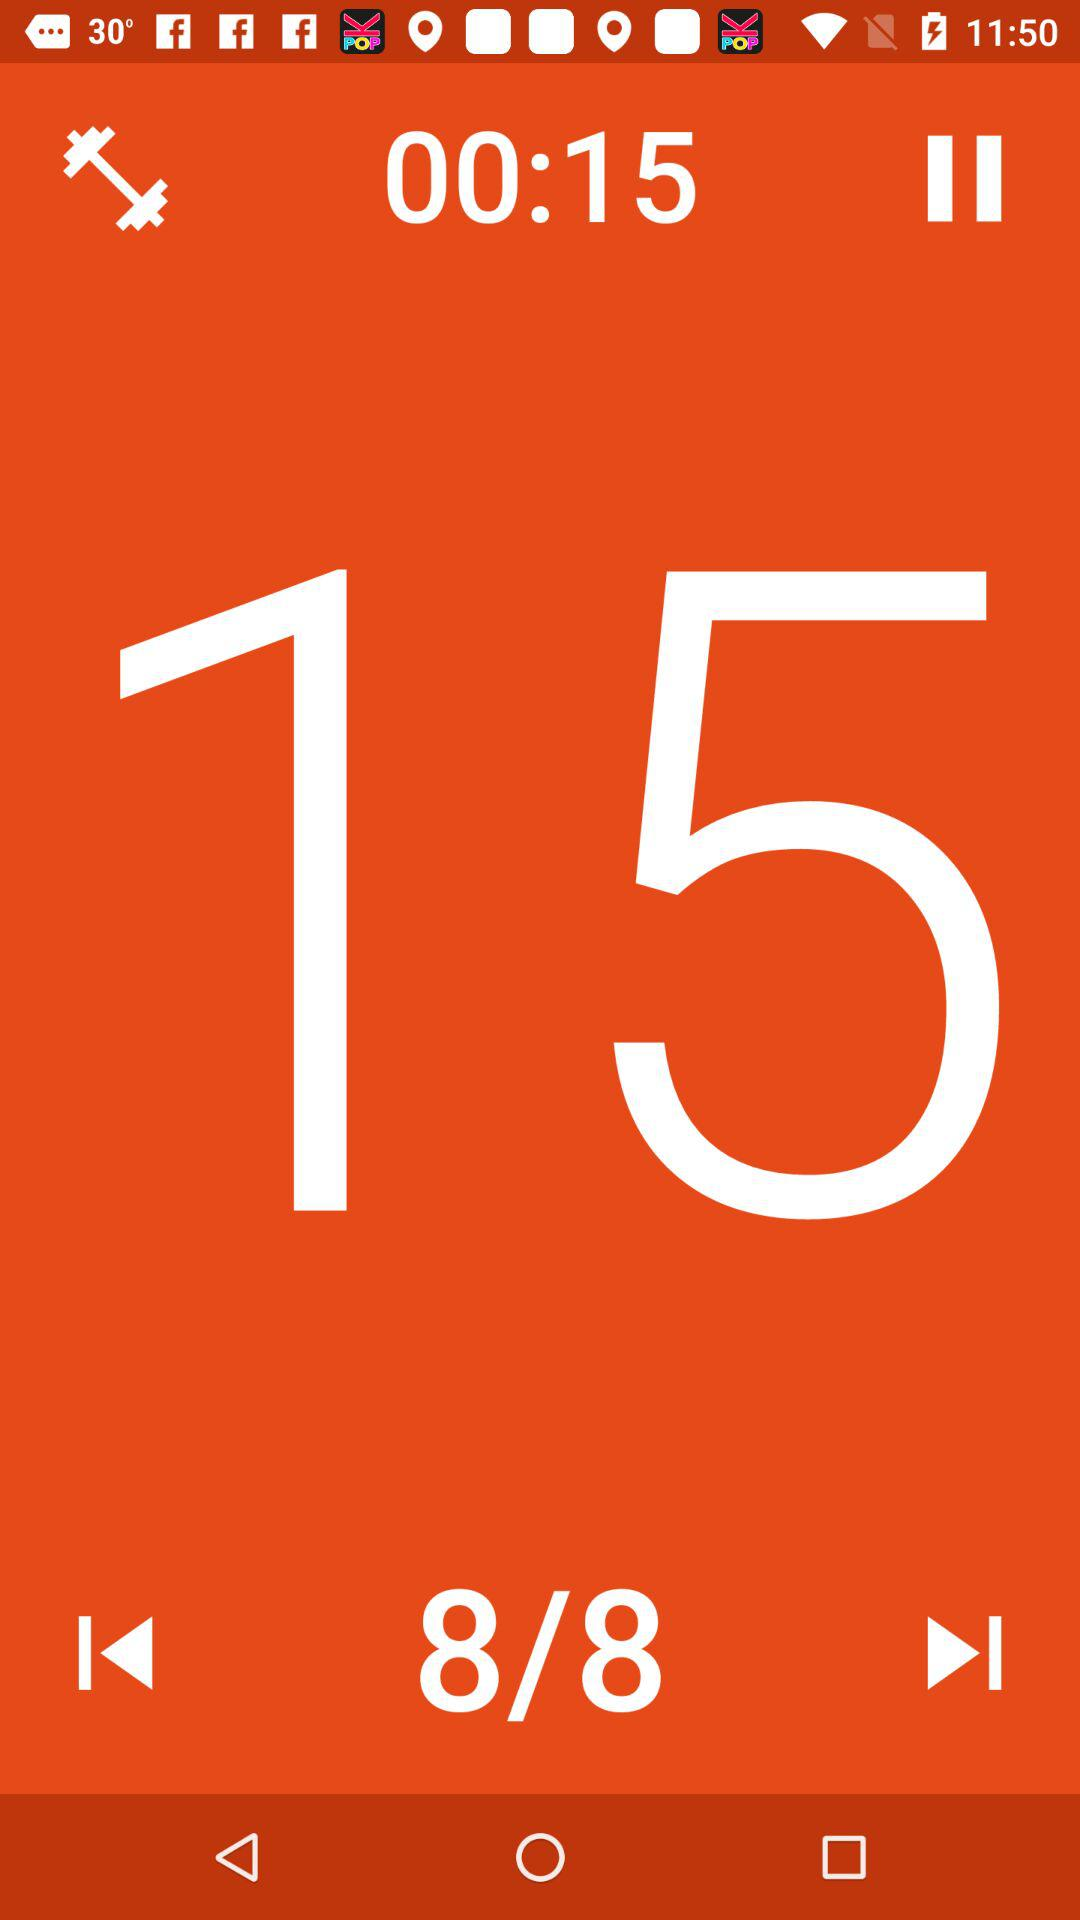Which slide are we on? You are on the eighth slide. 